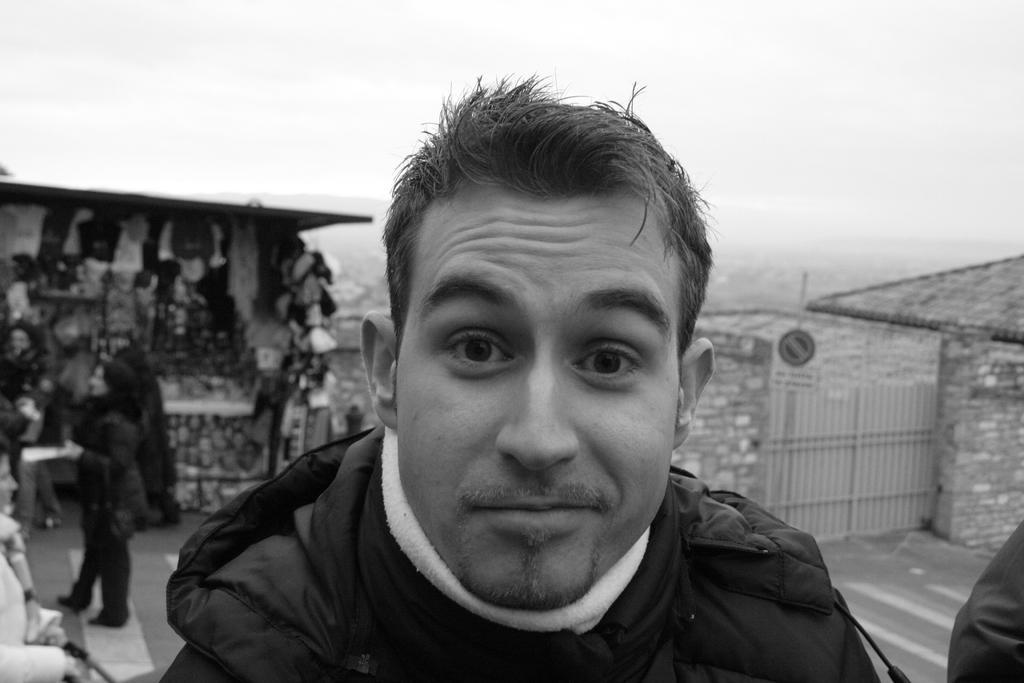In one or two sentences, can you explain what this image depicts? In this picture we can see a man in the front, on the left side there are some people standing, on the right side we can see a wall and a gate, there is the sky at the top of the picture, it is a black and white image. 